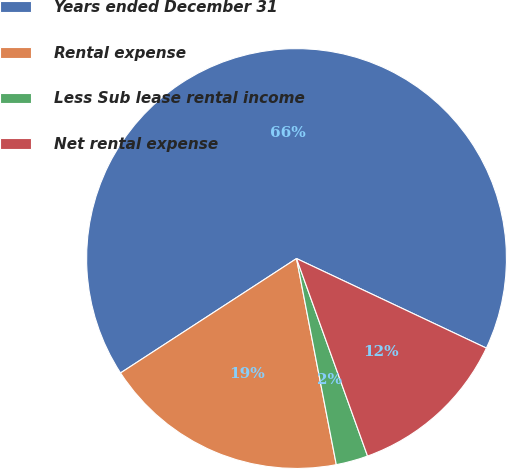Convert chart. <chart><loc_0><loc_0><loc_500><loc_500><pie_chart><fcel>Years ended December 31<fcel>Rental expense<fcel>Less Sub lease rental income<fcel>Net rental expense<nl><fcel>66.19%<fcel>18.86%<fcel>2.46%<fcel>12.49%<nl></chart> 